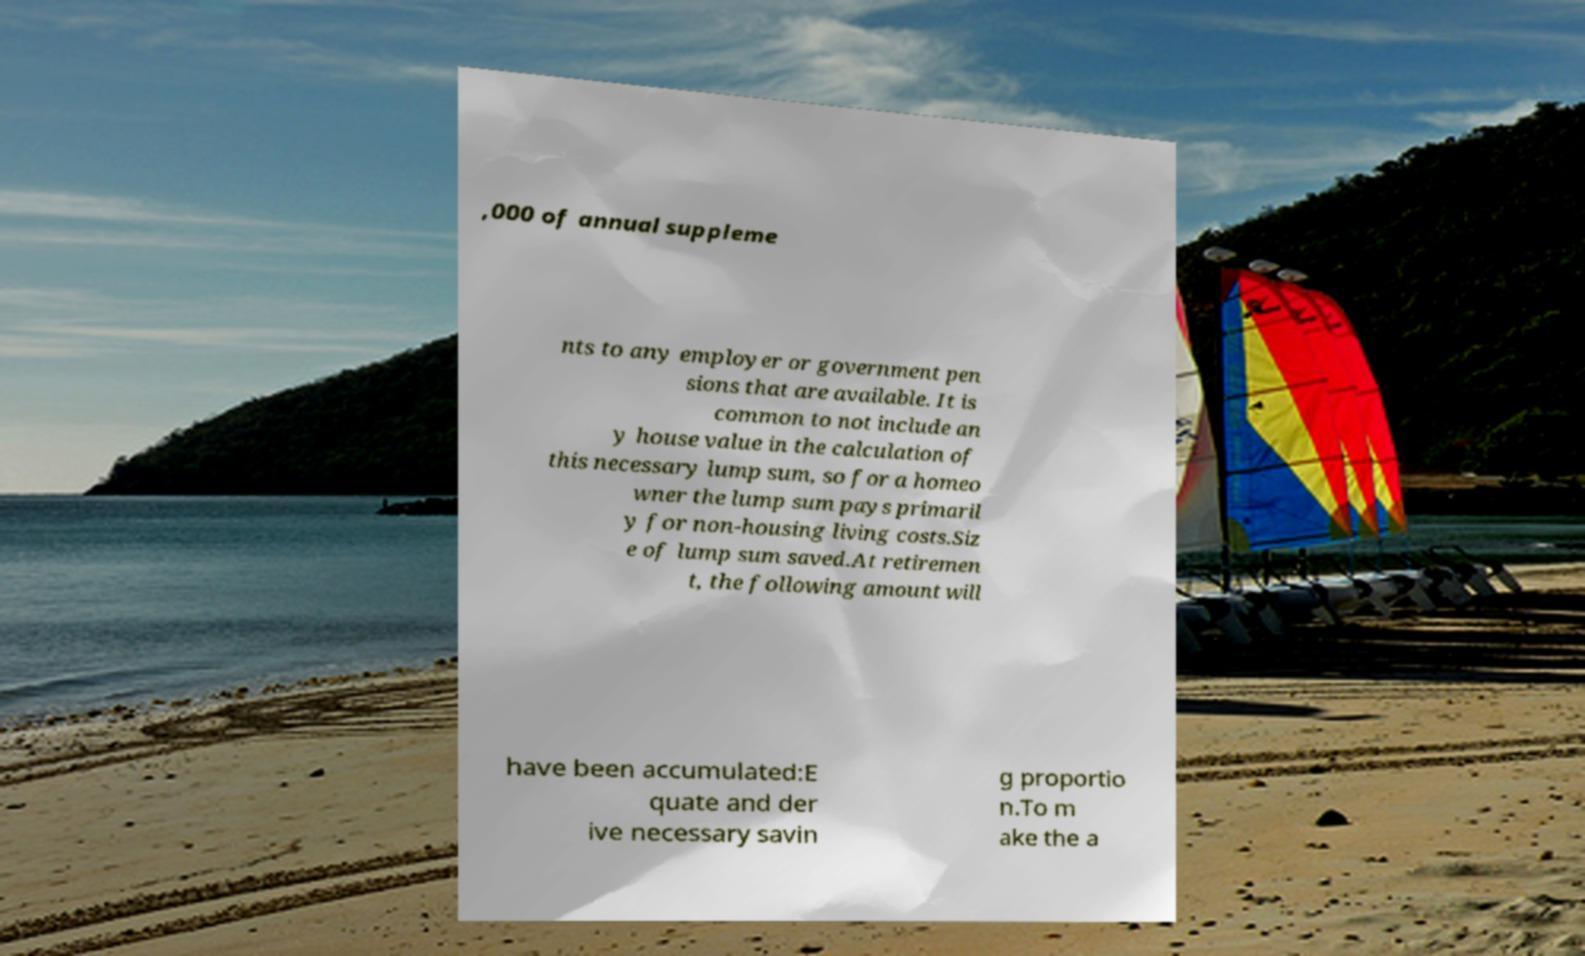For documentation purposes, I need the text within this image transcribed. Could you provide that? ,000 of annual suppleme nts to any employer or government pen sions that are available. It is common to not include an y house value in the calculation of this necessary lump sum, so for a homeo wner the lump sum pays primaril y for non-housing living costs.Siz e of lump sum saved.At retiremen t, the following amount will have been accumulated:E quate and der ive necessary savin g proportio n.To m ake the a 